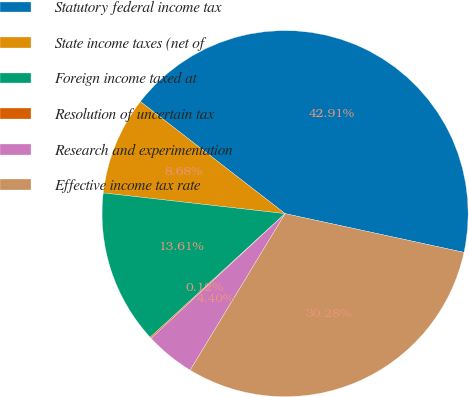Convert chart. <chart><loc_0><loc_0><loc_500><loc_500><pie_chart><fcel>Statutory federal income tax<fcel>State income taxes (net of<fcel>Foreign income taxed at<fcel>Resolution of uncertain tax<fcel>Research and experimentation<fcel>Effective income tax rate<nl><fcel>42.91%<fcel>8.68%<fcel>13.61%<fcel>0.12%<fcel>4.4%<fcel>30.28%<nl></chart> 